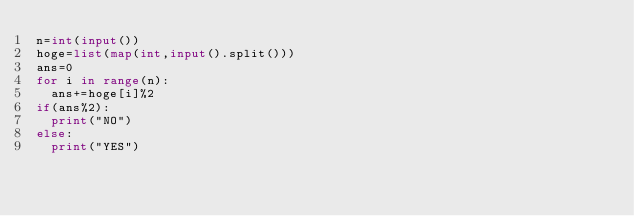<code> <loc_0><loc_0><loc_500><loc_500><_Python_>n=int(input())
hoge=list(map(int,input().split()))
ans=0
for i in range(n):
  ans+=hoge[i]%2
if(ans%2):
  print("NO")
else:
  print("YES")</code> 